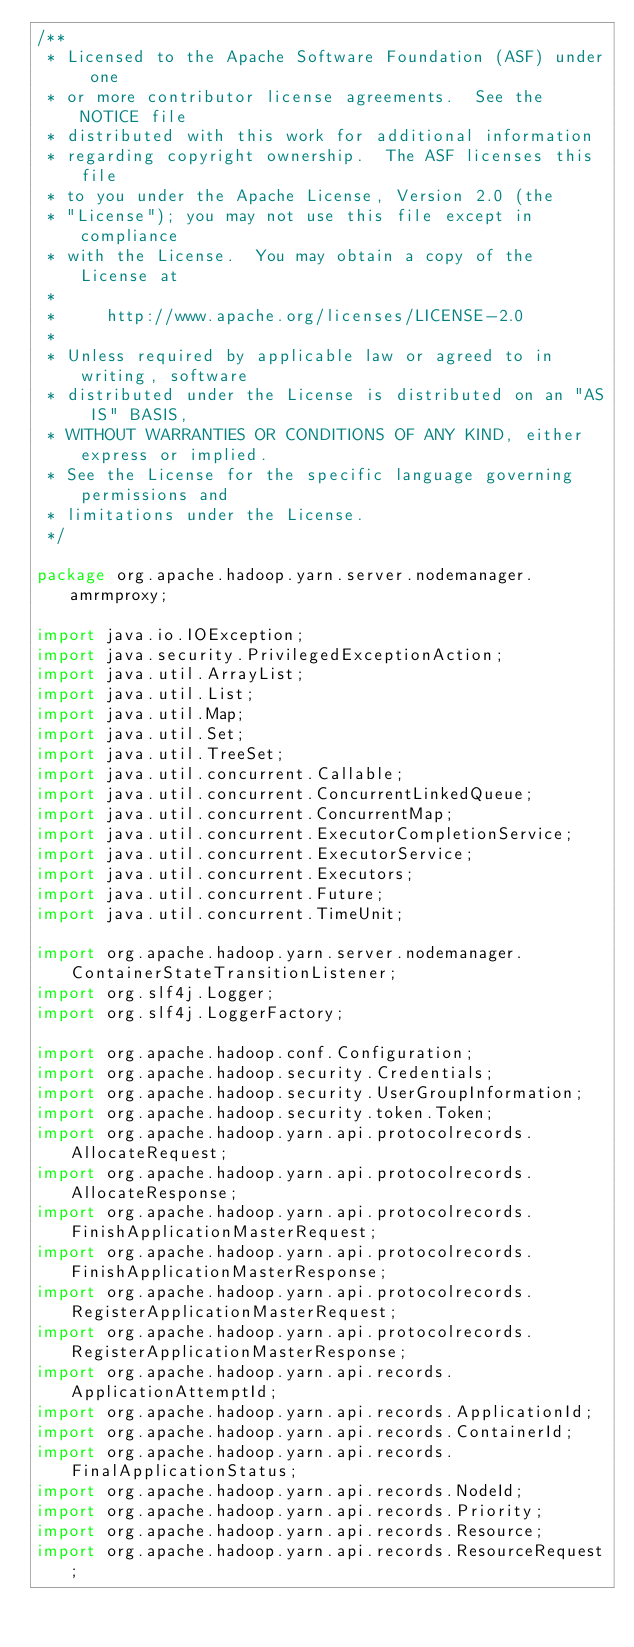Convert code to text. <code><loc_0><loc_0><loc_500><loc_500><_Java_>/**
 * Licensed to the Apache Software Foundation (ASF) under one
 * or more contributor license agreements.  See the NOTICE file
 * distributed with this work for additional information
 * regarding copyright ownership.  The ASF licenses this file
 * to you under the Apache License, Version 2.0 (the
 * "License"); you may not use this file except in compliance
 * with the License.  You may obtain a copy of the License at
 *
 *     http://www.apache.org/licenses/LICENSE-2.0
 *
 * Unless required by applicable law or agreed to in writing, software
 * distributed under the License is distributed on an "AS IS" BASIS,
 * WITHOUT WARRANTIES OR CONDITIONS OF ANY KIND, either express or implied.
 * See the License for the specific language governing permissions and
 * limitations under the License.
 */

package org.apache.hadoop.yarn.server.nodemanager.amrmproxy;

import java.io.IOException;
import java.security.PrivilegedExceptionAction;
import java.util.ArrayList;
import java.util.List;
import java.util.Map;
import java.util.Set;
import java.util.TreeSet;
import java.util.concurrent.Callable;
import java.util.concurrent.ConcurrentLinkedQueue;
import java.util.concurrent.ConcurrentMap;
import java.util.concurrent.ExecutorCompletionService;
import java.util.concurrent.ExecutorService;
import java.util.concurrent.Executors;
import java.util.concurrent.Future;
import java.util.concurrent.TimeUnit;

import org.apache.hadoop.yarn.server.nodemanager.ContainerStateTransitionListener;
import org.slf4j.Logger;
import org.slf4j.LoggerFactory;

import org.apache.hadoop.conf.Configuration;
import org.apache.hadoop.security.Credentials;
import org.apache.hadoop.security.UserGroupInformation;
import org.apache.hadoop.security.token.Token;
import org.apache.hadoop.yarn.api.protocolrecords.AllocateRequest;
import org.apache.hadoop.yarn.api.protocolrecords.AllocateResponse;
import org.apache.hadoop.yarn.api.protocolrecords.FinishApplicationMasterRequest;
import org.apache.hadoop.yarn.api.protocolrecords.FinishApplicationMasterResponse;
import org.apache.hadoop.yarn.api.protocolrecords.RegisterApplicationMasterRequest;
import org.apache.hadoop.yarn.api.protocolrecords.RegisterApplicationMasterResponse;
import org.apache.hadoop.yarn.api.records.ApplicationAttemptId;
import org.apache.hadoop.yarn.api.records.ApplicationId;
import org.apache.hadoop.yarn.api.records.ContainerId;
import org.apache.hadoop.yarn.api.records.FinalApplicationStatus;
import org.apache.hadoop.yarn.api.records.NodeId;
import org.apache.hadoop.yarn.api.records.Priority;
import org.apache.hadoop.yarn.api.records.Resource;
import org.apache.hadoop.yarn.api.records.ResourceRequest;</code> 